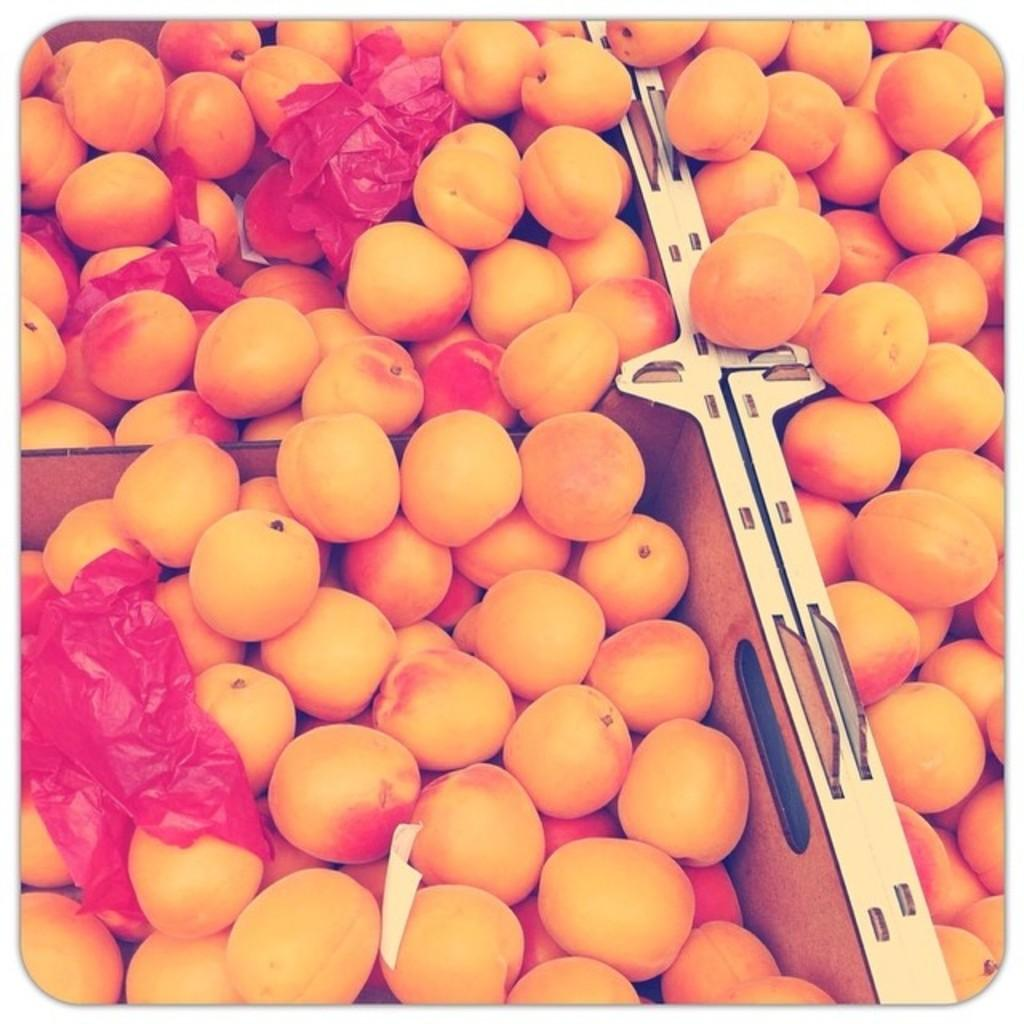What type of food can be seen in the image? There are fruits in the image. How are the fruits organized in the image? The fruits are arranged in boxes. What color are the covers of the boxes? The boxes have red covers. What type of police activity is happening in the image? There is no police activity present in the image; it features fruits arranged in boxes with red covers. What stage of growth are the fruits in the image? The stage of growth of the fruits cannot be determined from the image, as they are already arranged in boxes. 